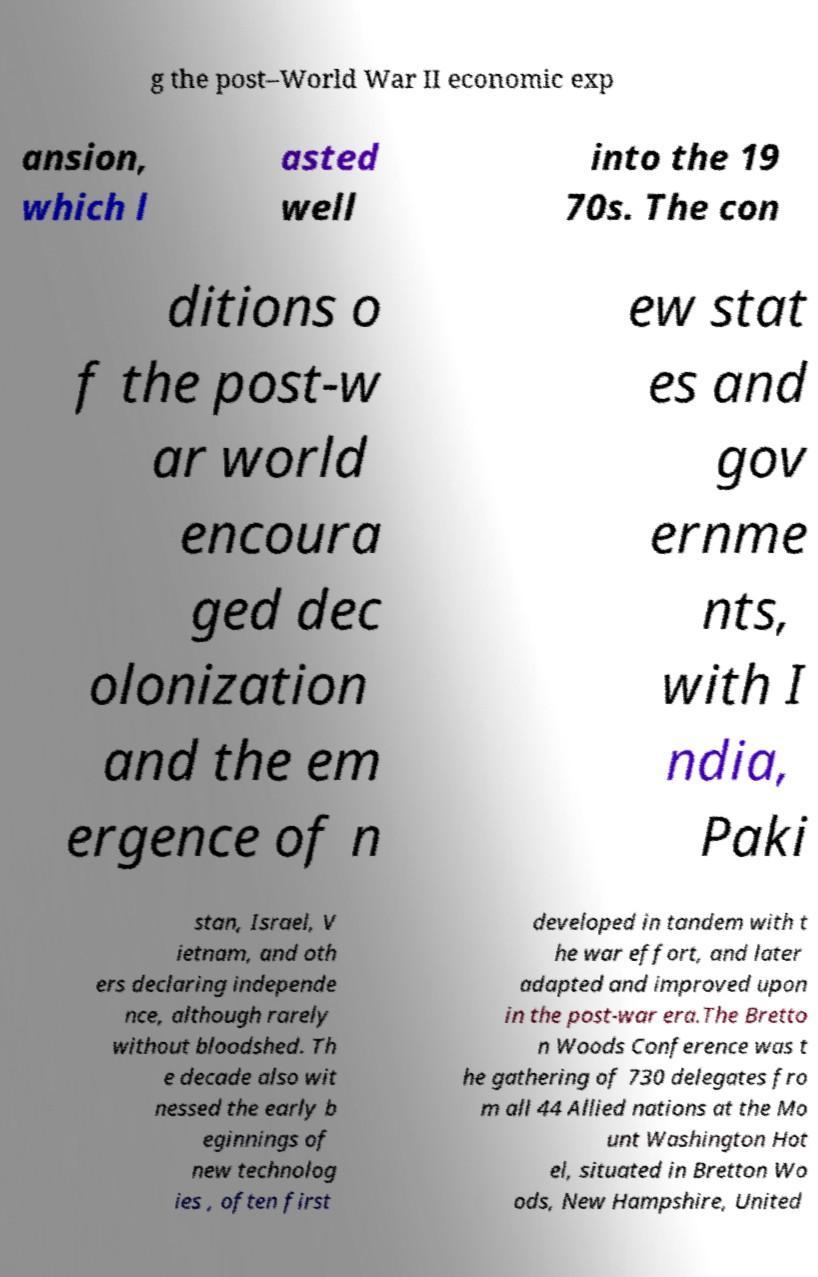Can you accurately transcribe the text from the provided image for me? g the post–World War II economic exp ansion, which l asted well into the 19 70s. The con ditions o f the post-w ar world encoura ged dec olonization and the em ergence of n ew stat es and gov ernme nts, with I ndia, Paki stan, Israel, V ietnam, and oth ers declaring independe nce, although rarely without bloodshed. Th e decade also wit nessed the early b eginnings of new technolog ies , often first developed in tandem with t he war effort, and later adapted and improved upon in the post-war era.The Bretto n Woods Conference was t he gathering of 730 delegates fro m all 44 Allied nations at the Mo unt Washington Hot el, situated in Bretton Wo ods, New Hampshire, United 